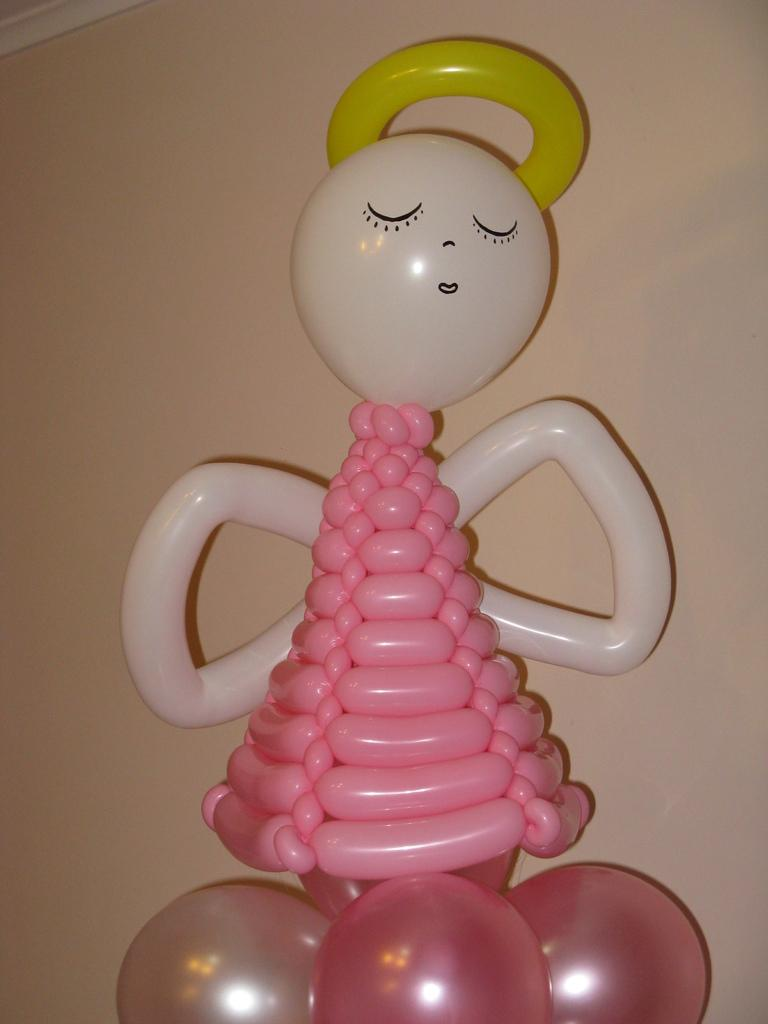What is the main subject of the image? The main subject of the image is a doll. What is the doll made of? The doll is made up of different shapes of balloons. How many eggs are visible in the image? There are no eggs visible in the image; it features a doll made up of different shapes of balloons. What type of crate is present in the image? There is no crate present in the image. 